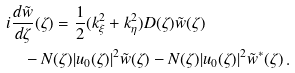Convert formula to latex. <formula><loc_0><loc_0><loc_500><loc_500>& i \frac { d \tilde { w } } { d \zeta } ( \zeta ) = \frac { 1 } { 2 } ( k _ { \xi } ^ { 2 } + k _ { \eta } ^ { 2 } ) D ( \zeta ) \tilde { w } ( \zeta ) \\ & \quad - N ( \zeta ) | u _ { 0 } ( \zeta ) | ^ { 2 } \tilde { w } ( \zeta ) - N ( \zeta ) | u _ { 0 } ( \zeta ) | ^ { 2 } \tilde { w } ^ { * } ( \zeta ) \, .</formula> 